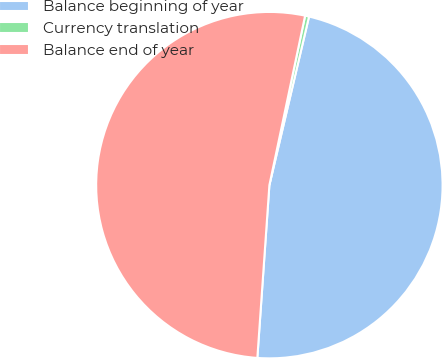<chart> <loc_0><loc_0><loc_500><loc_500><pie_chart><fcel>Balance beginning of year<fcel>Currency translation<fcel>Balance end of year<nl><fcel>47.43%<fcel>0.37%<fcel>52.2%<nl></chart> 